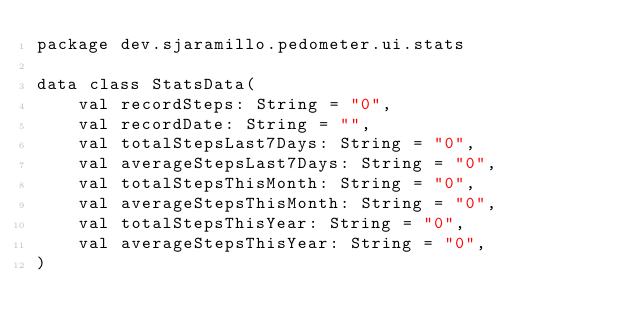<code> <loc_0><loc_0><loc_500><loc_500><_Kotlin_>package dev.sjaramillo.pedometer.ui.stats

data class StatsData(
    val recordSteps: String = "0",
    val recordDate: String = "",
    val totalStepsLast7Days: String = "0",
    val averageStepsLast7Days: String = "0",
    val totalStepsThisMonth: String = "0",
    val averageStepsThisMonth: String = "0",
    val totalStepsThisYear: String = "0",
    val averageStepsThisYear: String = "0",
)
</code> 